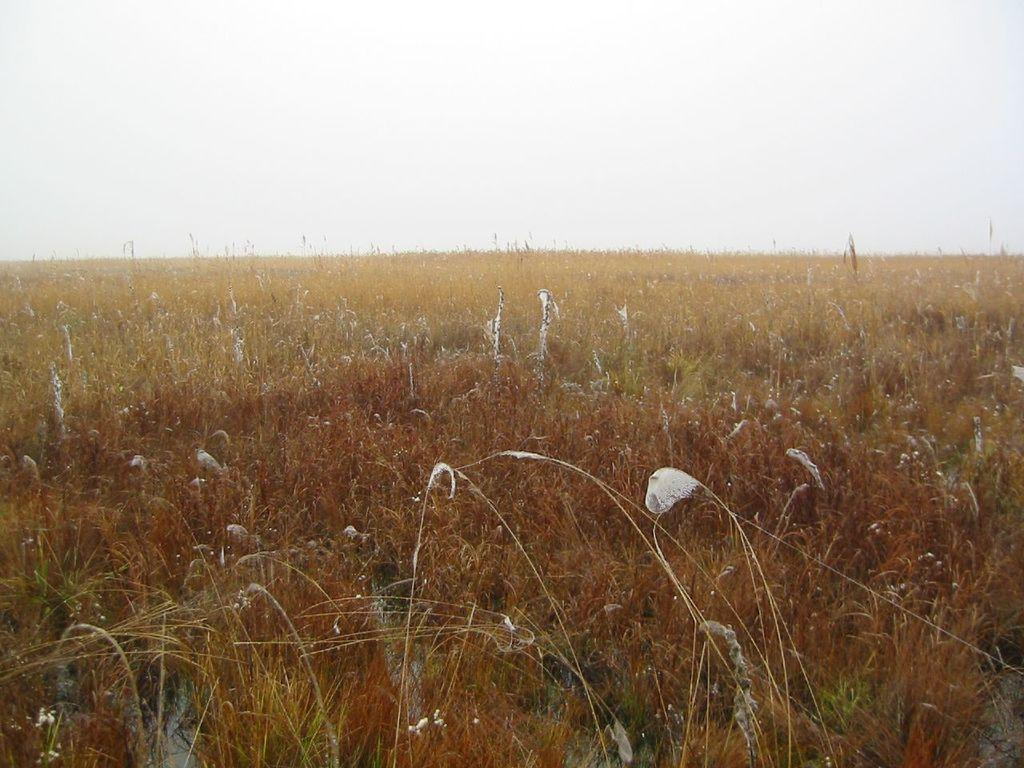What type of living organisms can be seen in the image? Plants can be seen in the image. What colors are present on the plants in the image? The plants have yellow, green, and orange colors. What can be seen in the background of the image? There is a sky visible in the background of the image. What type of muscle can be seen flexing in the image? There is no muscle present in the image; it features plants with yellow, green, and orange colors and a sky in the background. 